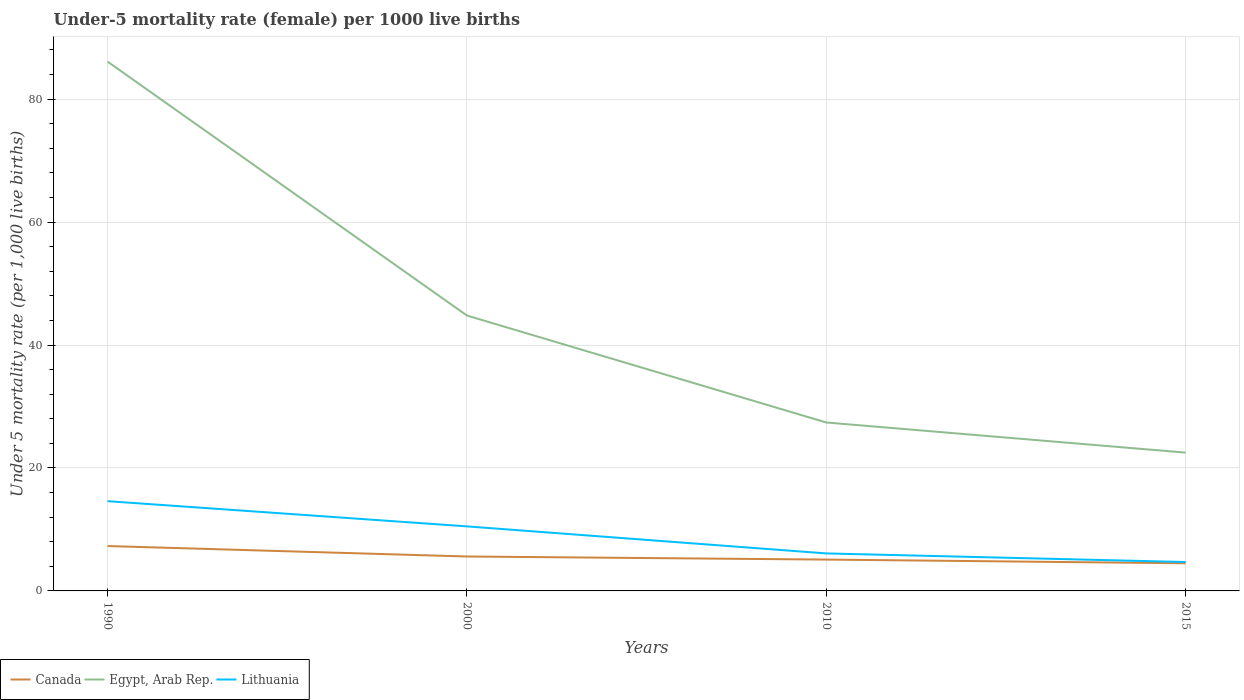How many different coloured lines are there?
Your response must be concise. 3. Does the line corresponding to Canada intersect with the line corresponding to Lithuania?
Your answer should be very brief. No. Is the number of lines equal to the number of legend labels?
Provide a short and direct response. Yes. Across all years, what is the maximum under-five mortality rate in Canada?
Make the answer very short. 4.5. In which year was the under-five mortality rate in Canada maximum?
Keep it short and to the point. 2015. What is the difference between the highest and the second highest under-five mortality rate in Lithuania?
Your response must be concise. 9.9. What is the difference between the highest and the lowest under-five mortality rate in Canada?
Your answer should be very brief. 1. How many years are there in the graph?
Provide a short and direct response. 4. What is the difference between two consecutive major ticks on the Y-axis?
Ensure brevity in your answer.  20. Are the values on the major ticks of Y-axis written in scientific E-notation?
Provide a succinct answer. No. Where does the legend appear in the graph?
Give a very brief answer. Bottom left. What is the title of the graph?
Keep it short and to the point. Under-5 mortality rate (female) per 1000 live births. What is the label or title of the X-axis?
Offer a very short reply. Years. What is the label or title of the Y-axis?
Your response must be concise. Under 5 mortality rate (per 1,0 live births). What is the Under 5 mortality rate (per 1,000 live births) in Egypt, Arab Rep. in 1990?
Ensure brevity in your answer.  86.1. What is the Under 5 mortality rate (per 1,000 live births) in Canada in 2000?
Your answer should be very brief. 5.6. What is the Under 5 mortality rate (per 1,000 live births) of Egypt, Arab Rep. in 2000?
Provide a succinct answer. 44.8. What is the Under 5 mortality rate (per 1,000 live births) in Egypt, Arab Rep. in 2010?
Your answer should be compact. 27.4. What is the Under 5 mortality rate (per 1,000 live births) in Canada in 2015?
Ensure brevity in your answer.  4.5. Across all years, what is the maximum Under 5 mortality rate (per 1,000 live births) in Egypt, Arab Rep.?
Ensure brevity in your answer.  86.1. What is the total Under 5 mortality rate (per 1,000 live births) in Canada in the graph?
Ensure brevity in your answer.  22.5. What is the total Under 5 mortality rate (per 1,000 live births) in Egypt, Arab Rep. in the graph?
Your answer should be compact. 180.8. What is the total Under 5 mortality rate (per 1,000 live births) of Lithuania in the graph?
Keep it short and to the point. 35.9. What is the difference between the Under 5 mortality rate (per 1,000 live births) of Canada in 1990 and that in 2000?
Make the answer very short. 1.7. What is the difference between the Under 5 mortality rate (per 1,000 live births) in Egypt, Arab Rep. in 1990 and that in 2000?
Offer a terse response. 41.3. What is the difference between the Under 5 mortality rate (per 1,000 live births) of Lithuania in 1990 and that in 2000?
Provide a succinct answer. 4.1. What is the difference between the Under 5 mortality rate (per 1,000 live births) of Canada in 1990 and that in 2010?
Give a very brief answer. 2.2. What is the difference between the Under 5 mortality rate (per 1,000 live births) in Egypt, Arab Rep. in 1990 and that in 2010?
Your response must be concise. 58.7. What is the difference between the Under 5 mortality rate (per 1,000 live births) of Lithuania in 1990 and that in 2010?
Offer a very short reply. 8.5. What is the difference between the Under 5 mortality rate (per 1,000 live births) in Canada in 1990 and that in 2015?
Provide a short and direct response. 2.8. What is the difference between the Under 5 mortality rate (per 1,000 live births) in Egypt, Arab Rep. in 1990 and that in 2015?
Provide a succinct answer. 63.6. What is the difference between the Under 5 mortality rate (per 1,000 live births) in Lithuania in 1990 and that in 2015?
Offer a terse response. 9.9. What is the difference between the Under 5 mortality rate (per 1,000 live births) of Canada in 2000 and that in 2010?
Provide a succinct answer. 0.5. What is the difference between the Under 5 mortality rate (per 1,000 live births) of Egypt, Arab Rep. in 2000 and that in 2010?
Provide a short and direct response. 17.4. What is the difference between the Under 5 mortality rate (per 1,000 live births) of Lithuania in 2000 and that in 2010?
Your answer should be very brief. 4.4. What is the difference between the Under 5 mortality rate (per 1,000 live births) in Egypt, Arab Rep. in 2000 and that in 2015?
Offer a very short reply. 22.3. What is the difference between the Under 5 mortality rate (per 1,000 live births) in Canada in 1990 and the Under 5 mortality rate (per 1,000 live births) in Egypt, Arab Rep. in 2000?
Your answer should be very brief. -37.5. What is the difference between the Under 5 mortality rate (per 1,000 live births) in Egypt, Arab Rep. in 1990 and the Under 5 mortality rate (per 1,000 live births) in Lithuania in 2000?
Give a very brief answer. 75.6. What is the difference between the Under 5 mortality rate (per 1,000 live births) of Canada in 1990 and the Under 5 mortality rate (per 1,000 live births) of Egypt, Arab Rep. in 2010?
Ensure brevity in your answer.  -20.1. What is the difference between the Under 5 mortality rate (per 1,000 live births) of Canada in 1990 and the Under 5 mortality rate (per 1,000 live births) of Lithuania in 2010?
Keep it short and to the point. 1.2. What is the difference between the Under 5 mortality rate (per 1,000 live births) of Canada in 1990 and the Under 5 mortality rate (per 1,000 live births) of Egypt, Arab Rep. in 2015?
Offer a terse response. -15.2. What is the difference between the Under 5 mortality rate (per 1,000 live births) of Egypt, Arab Rep. in 1990 and the Under 5 mortality rate (per 1,000 live births) of Lithuania in 2015?
Ensure brevity in your answer.  81.4. What is the difference between the Under 5 mortality rate (per 1,000 live births) of Canada in 2000 and the Under 5 mortality rate (per 1,000 live births) of Egypt, Arab Rep. in 2010?
Give a very brief answer. -21.8. What is the difference between the Under 5 mortality rate (per 1,000 live births) in Canada in 2000 and the Under 5 mortality rate (per 1,000 live births) in Lithuania in 2010?
Provide a short and direct response. -0.5. What is the difference between the Under 5 mortality rate (per 1,000 live births) in Egypt, Arab Rep. in 2000 and the Under 5 mortality rate (per 1,000 live births) in Lithuania in 2010?
Provide a succinct answer. 38.7. What is the difference between the Under 5 mortality rate (per 1,000 live births) of Canada in 2000 and the Under 5 mortality rate (per 1,000 live births) of Egypt, Arab Rep. in 2015?
Your answer should be compact. -16.9. What is the difference between the Under 5 mortality rate (per 1,000 live births) in Canada in 2000 and the Under 5 mortality rate (per 1,000 live births) in Lithuania in 2015?
Ensure brevity in your answer.  0.9. What is the difference between the Under 5 mortality rate (per 1,000 live births) in Egypt, Arab Rep. in 2000 and the Under 5 mortality rate (per 1,000 live births) in Lithuania in 2015?
Ensure brevity in your answer.  40.1. What is the difference between the Under 5 mortality rate (per 1,000 live births) in Canada in 2010 and the Under 5 mortality rate (per 1,000 live births) in Egypt, Arab Rep. in 2015?
Your answer should be compact. -17.4. What is the difference between the Under 5 mortality rate (per 1,000 live births) of Egypt, Arab Rep. in 2010 and the Under 5 mortality rate (per 1,000 live births) of Lithuania in 2015?
Ensure brevity in your answer.  22.7. What is the average Under 5 mortality rate (per 1,000 live births) of Canada per year?
Make the answer very short. 5.62. What is the average Under 5 mortality rate (per 1,000 live births) in Egypt, Arab Rep. per year?
Offer a very short reply. 45.2. What is the average Under 5 mortality rate (per 1,000 live births) in Lithuania per year?
Your answer should be very brief. 8.97. In the year 1990, what is the difference between the Under 5 mortality rate (per 1,000 live births) in Canada and Under 5 mortality rate (per 1,000 live births) in Egypt, Arab Rep.?
Give a very brief answer. -78.8. In the year 1990, what is the difference between the Under 5 mortality rate (per 1,000 live births) of Egypt, Arab Rep. and Under 5 mortality rate (per 1,000 live births) of Lithuania?
Give a very brief answer. 71.5. In the year 2000, what is the difference between the Under 5 mortality rate (per 1,000 live births) of Canada and Under 5 mortality rate (per 1,000 live births) of Egypt, Arab Rep.?
Your answer should be compact. -39.2. In the year 2000, what is the difference between the Under 5 mortality rate (per 1,000 live births) in Canada and Under 5 mortality rate (per 1,000 live births) in Lithuania?
Offer a terse response. -4.9. In the year 2000, what is the difference between the Under 5 mortality rate (per 1,000 live births) in Egypt, Arab Rep. and Under 5 mortality rate (per 1,000 live births) in Lithuania?
Your answer should be very brief. 34.3. In the year 2010, what is the difference between the Under 5 mortality rate (per 1,000 live births) in Canada and Under 5 mortality rate (per 1,000 live births) in Egypt, Arab Rep.?
Make the answer very short. -22.3. In the year 2010, what is the difference between the Under 5 mortality rate (per 1,000 live births) of Canada and Under 5 mortality rate (per 1,000 live births) of Lithuania?
Your answer should be compact. -1. In the year 2010, what is the difference between the Under 5 mortality rate (per 1,000 live births) of Egypt, Arab Rep. and Under 5 mortality rate (per 1,000 live births) of Lithuania?
Keep it short and to the point. 21.3. What is the ratio of the Under 5 mortality rate (per 1,000 live births) of Canada in 1990 to that in 2000?
Ensure brevity in your answer.  1.3. What is the ratio of the Under 5 mortality rate (per 1,000 live births) in Egypt, Arab Rep. in 1990 to that in 2000?
Ensure brevity in your answer.  1.92. What is the ratio of the Under 5 mortality rate (per 1,000 live births) in Lithuania in 1990 to that in 2000?
Make the answer very short. 1.39. What is the ratio of the Under 5 mortality rate (per 1,000 live births) of Canada in 1990 to that in 2010?
Ensure brevity in your answer.  1.43. What is the ratio of the Under 5 mortality rate (per 1,000 live births) of Egypt, Arab Rep. in 1990 to that in 2010?
Provide a succinct answer. 3.14. What is the ratio of the Under 5 mortality rate (per 1,000 live births) of Lithuania in 1990 to that in 2010?
Keep it short and to the point. 2.39. What is the ratio of the Under 5 mortality rate (per 1,000 live births) in Canada in 1990 to that in 2015?
Your response must be concise. 1.62. What is the ratio of the Under 5 mortality rate (per 1,000 live births) in Egypt, Arab Rep. in 1990 to that in 2015?
Give a very brief answer. 3.83. What is the ratio of the Under 5 mortality rate (per 1,000 live births) of Lithuania in 1990 to that in 2015?
Your answer should be very brief. 3.11. What is the ratio of the Under 5 mortality rate (per 1,000 live births) of Canada in 2000 to that in 2010?
Offer a very short reply. 1.1. What is the ratio of the Under 5 mortality rate (per 1,000 live births) of Egypt, Arab Rep. in 2000 to that in 2010?
Offer a terse response. 1.64. What is the ratio of the Under 5 mortality rate (per 1,000 live births) of Lithuania in 2000 to that in 2010?
Offer a terse response. 1.72. What is the ratio of the Under 5 mortality rate (per 1,000 live births) of Canada in 2000 to that in 2015?
Keep it short and to the point. 1.24. What is the ratio of the Under 5 mortality rate (per 1,000 live births) of Egypt, Arab Rep. in 2000 to that in 2015?
Ensure brevity in your answer.  1.99. What is the ratio of the Under 5 mortality rate (per 1,000 live births) in Lithuania in 2000 to that in 2015?
Your answer should be very brief. 2.23. What is the ratio of the Under 5 mortality rate (per 1,000 live births) in Canada in 2010 to that in 2015?
Provide a succinct answer. 1.13. What is the ratio of the Under 5 mortality rate (per 1,000 live births) in Egypt, Arab Rep. in 2010 to that in 2015?
Your answer should be very brief. 1.22. What is the ratio of the Under 5 mortality rate (per 1,000 live births) in Lithuania in 2010 to that in 2015?
Ensure brevity in your answer.  1.3. What is the difference between the highest and the second highest Under 5 mortality rate (per 1,000 live births) of Canada?
Offer a terse response. 1.7. What is the difference between the highest and the second highest Under 5 mortality rate (per 1,000 live births) of Egypt, Arab Rep.?
Give a very brief answer. 41.3. What is the difference between the highest and the lowest Under 5 mortality rate (per 1,000 live births) of Egypt, Arab Rep.?
Provide a short and direct response. 63.6. What is the difference between the highest and the lowest Under 5 mortality rate (per 1,000 live births) of Lithuania?
Your response must be concise. 9.9. 